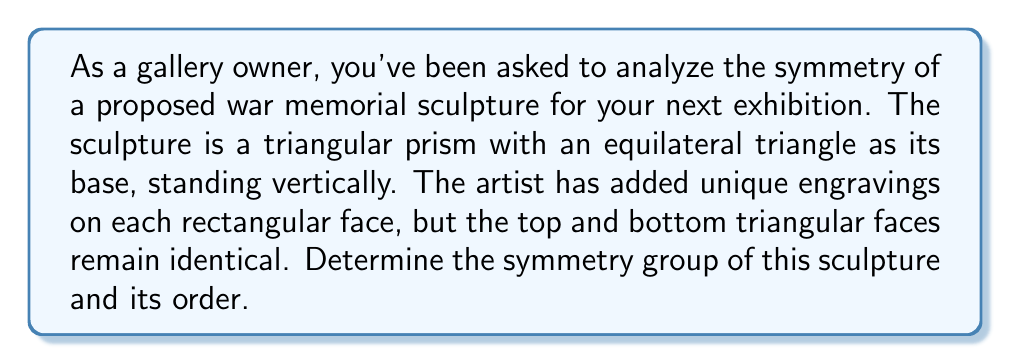Give your solution to this math problem. To determine the symmetry group of the sculpture, we need to identify all the symmetry operations that leave the sculpture unchanged. Let's analyze this step-by-step:

1) Rotational symmetry:
   - The sculpture has a 3-fold rotational symmetry around its vertical axis (120° rotations).
   - There are no other rotational symmetries due to the unique engravings on each rectangular face.

2) Reflection symmetry:
   - There are no reflection symmetries because the rectangular faces are uniquely engraved.

3) Identity:
   - The identity operation (doing nothing) is always a symmetry.

4) Vertical flip:
   - Since the top and bottom triangular faces are identical, flipping the sculpture upside down is a symmetry operation.

The symmetry operations we've identified are:
- Identity (e)
- 120° rotation (r)
- 240° rotation (r²)
- Vertical flip (f)
- 120° rotation followed by vertical flip (rf)
- 240° rotation followed by vertical flip (r²f)

These six operations form a group under composition. This group is isomorphic to $D_3$, the dihedral group of order 6.

To verify this, we can check the defining relations of $D_3$:
$$r^3 = e$$
$$f^2 = e$$
$$frf = r^2$$

The order of this group is 6, as we have identified 6 distinct symmetry operations.
Answer: The symmetry group of the sculpture is $D_3$ (dihedral group of order 6), and its order is 6. 